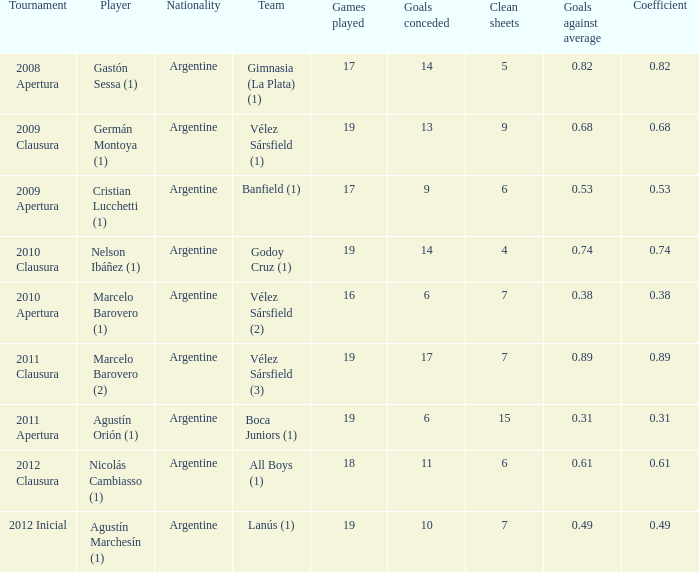What is the coefficient for agustín marchesín (1)? 0.49. 